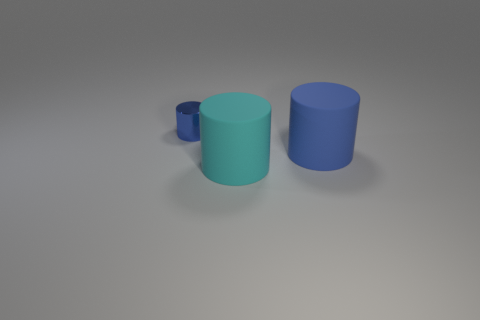Subtract all tiny shiny cylinders. How many cylinders are left? 2 Subtract all red spheres. How many blue cylinders are left? 2 Add 3 blue shiny things. How many objects exist? 6 Subtract all purple cylinders. Subtract all red spheres. How many cylinders are left? 3 Subtract all tiny blue metallic cylinders. Subtract all small yellow rubber spheres. How many objects are left? 2 Add 3 rubber cylinders. How many rubber cylinders are left? 5 Add 2 tiny gray things. How many tiny gray things exist? 2 Subtract 0 green cylinders. How many objects are left? 3 